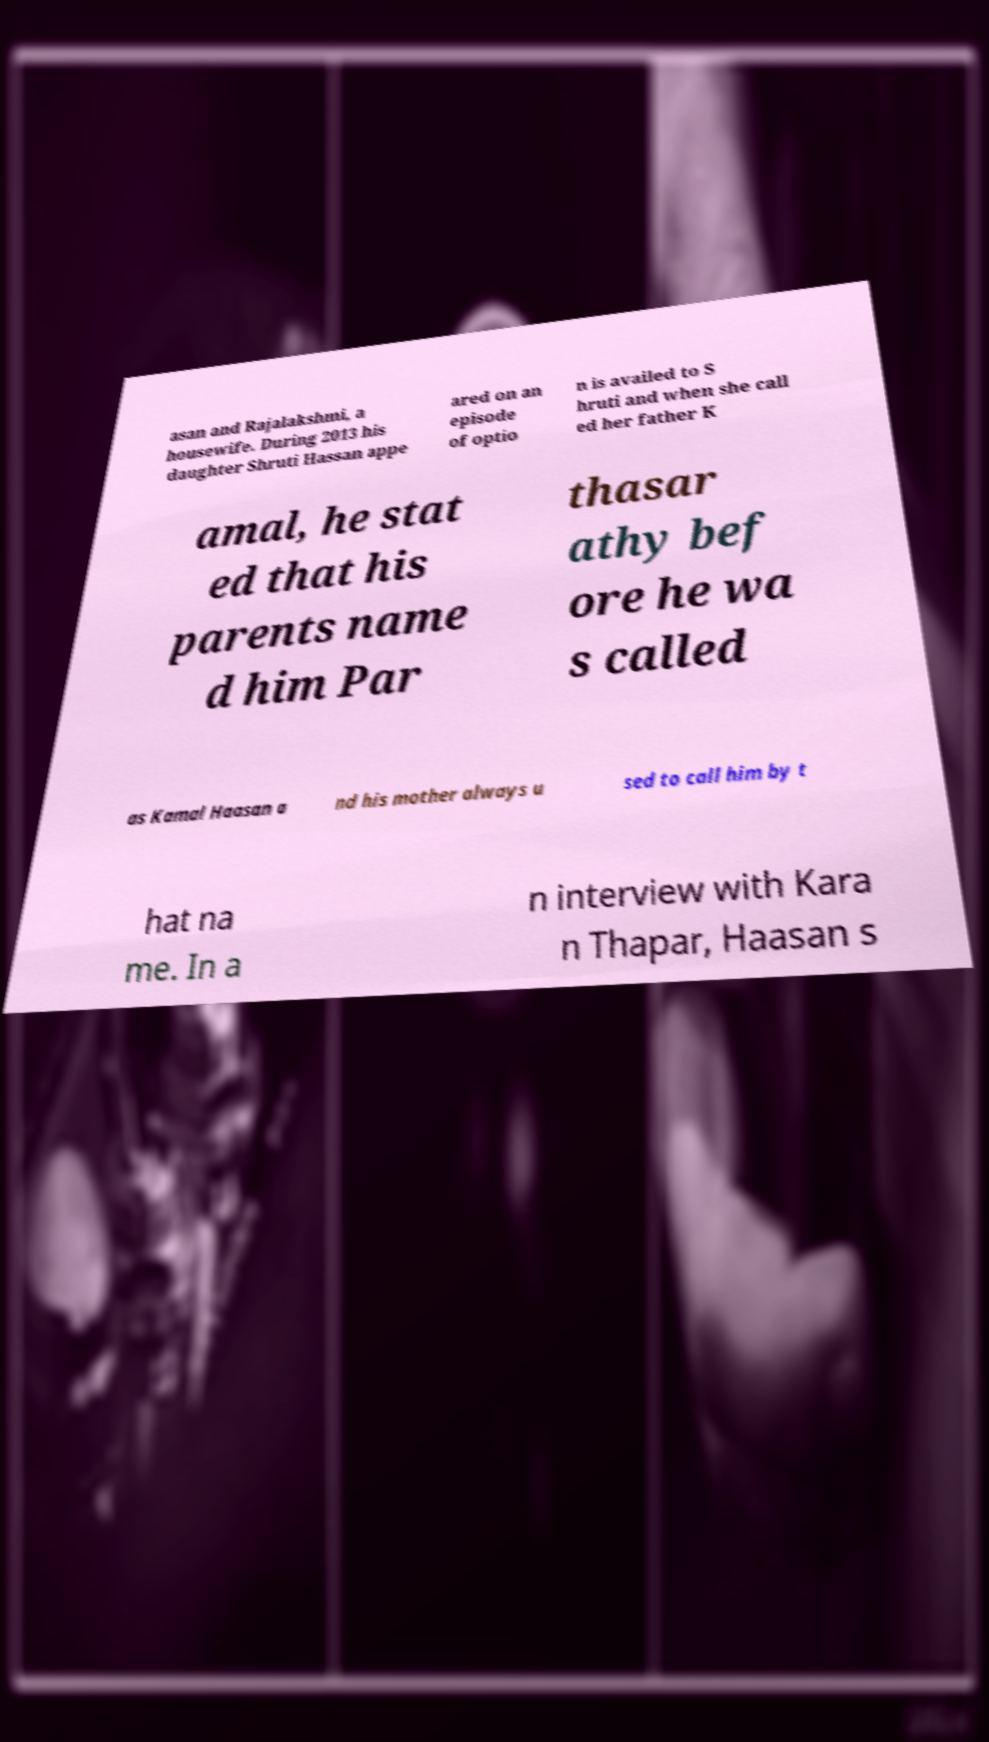Please identify and transcribe the text found in this image. asan and Rajalakshmi, a housewife. During 2013 his daughter Shruti Hassan appe ared on an episode of optio n is availed to S hruti and when she call ed her father K amal, he stat ed that his parents name d him Par thasar athy bef ore he wa s called as Kamal Haasan a nd his mother always u sed to call him by t hat na me. In a n interview with Kara n Thapar, Haasan s 